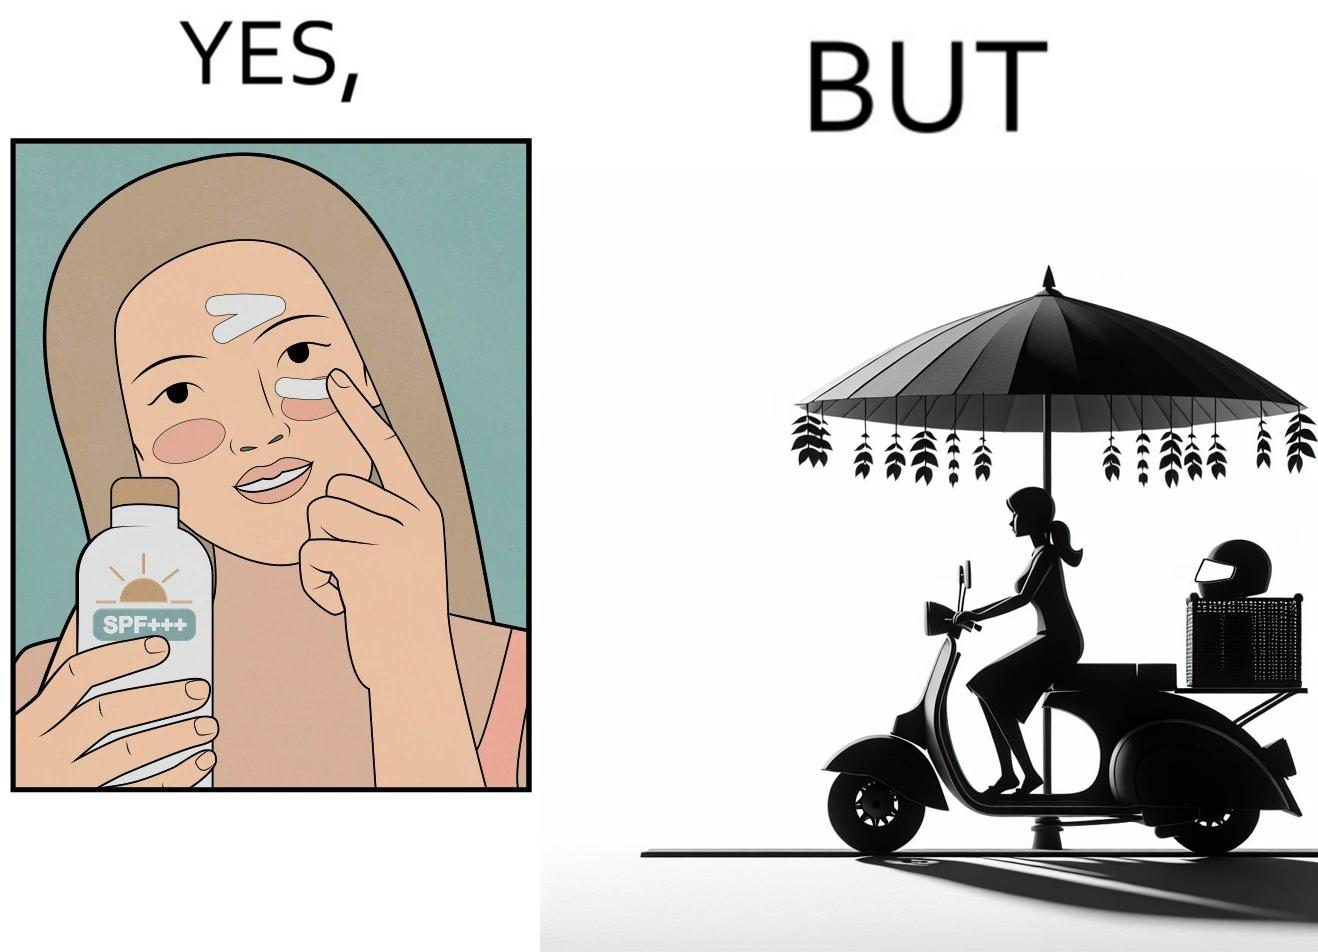Is this a satirical image? Yes, this image is satirical. 